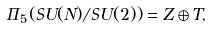<formula> <loc_0><loc_0><loc_500><loc_500>\Pi _ { 5 } ( S U ( N ) / S U ( 2 ) ) = Z \oplus T ,</formula> 